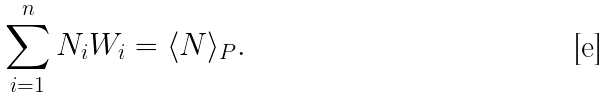<formula> <loc_0><loc_0><loc_500><loc_500>\sum _ { i = 1 } ^ { n } N _ { i } W _ { i } = \langle N \rangle _ { P } .</formula> 